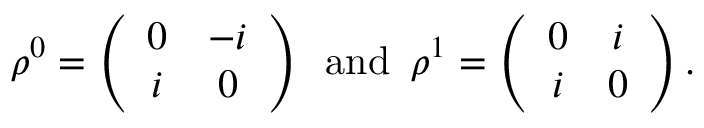Convert formula to latex. <formula><loc_0><loc_0><loc_500><loc_500>\rho ^ { 0 } = \left ( \begin{array} { c c } { 0 } & { - i } \\ { i } & { 0 } \end{array} \right ) \, a n d \, \rho ^ { 1 } = \left ( \begin{array} { c c } { 0 } & { i } \\ { i } & { 0 } \end{array} \right ) .</formula> 